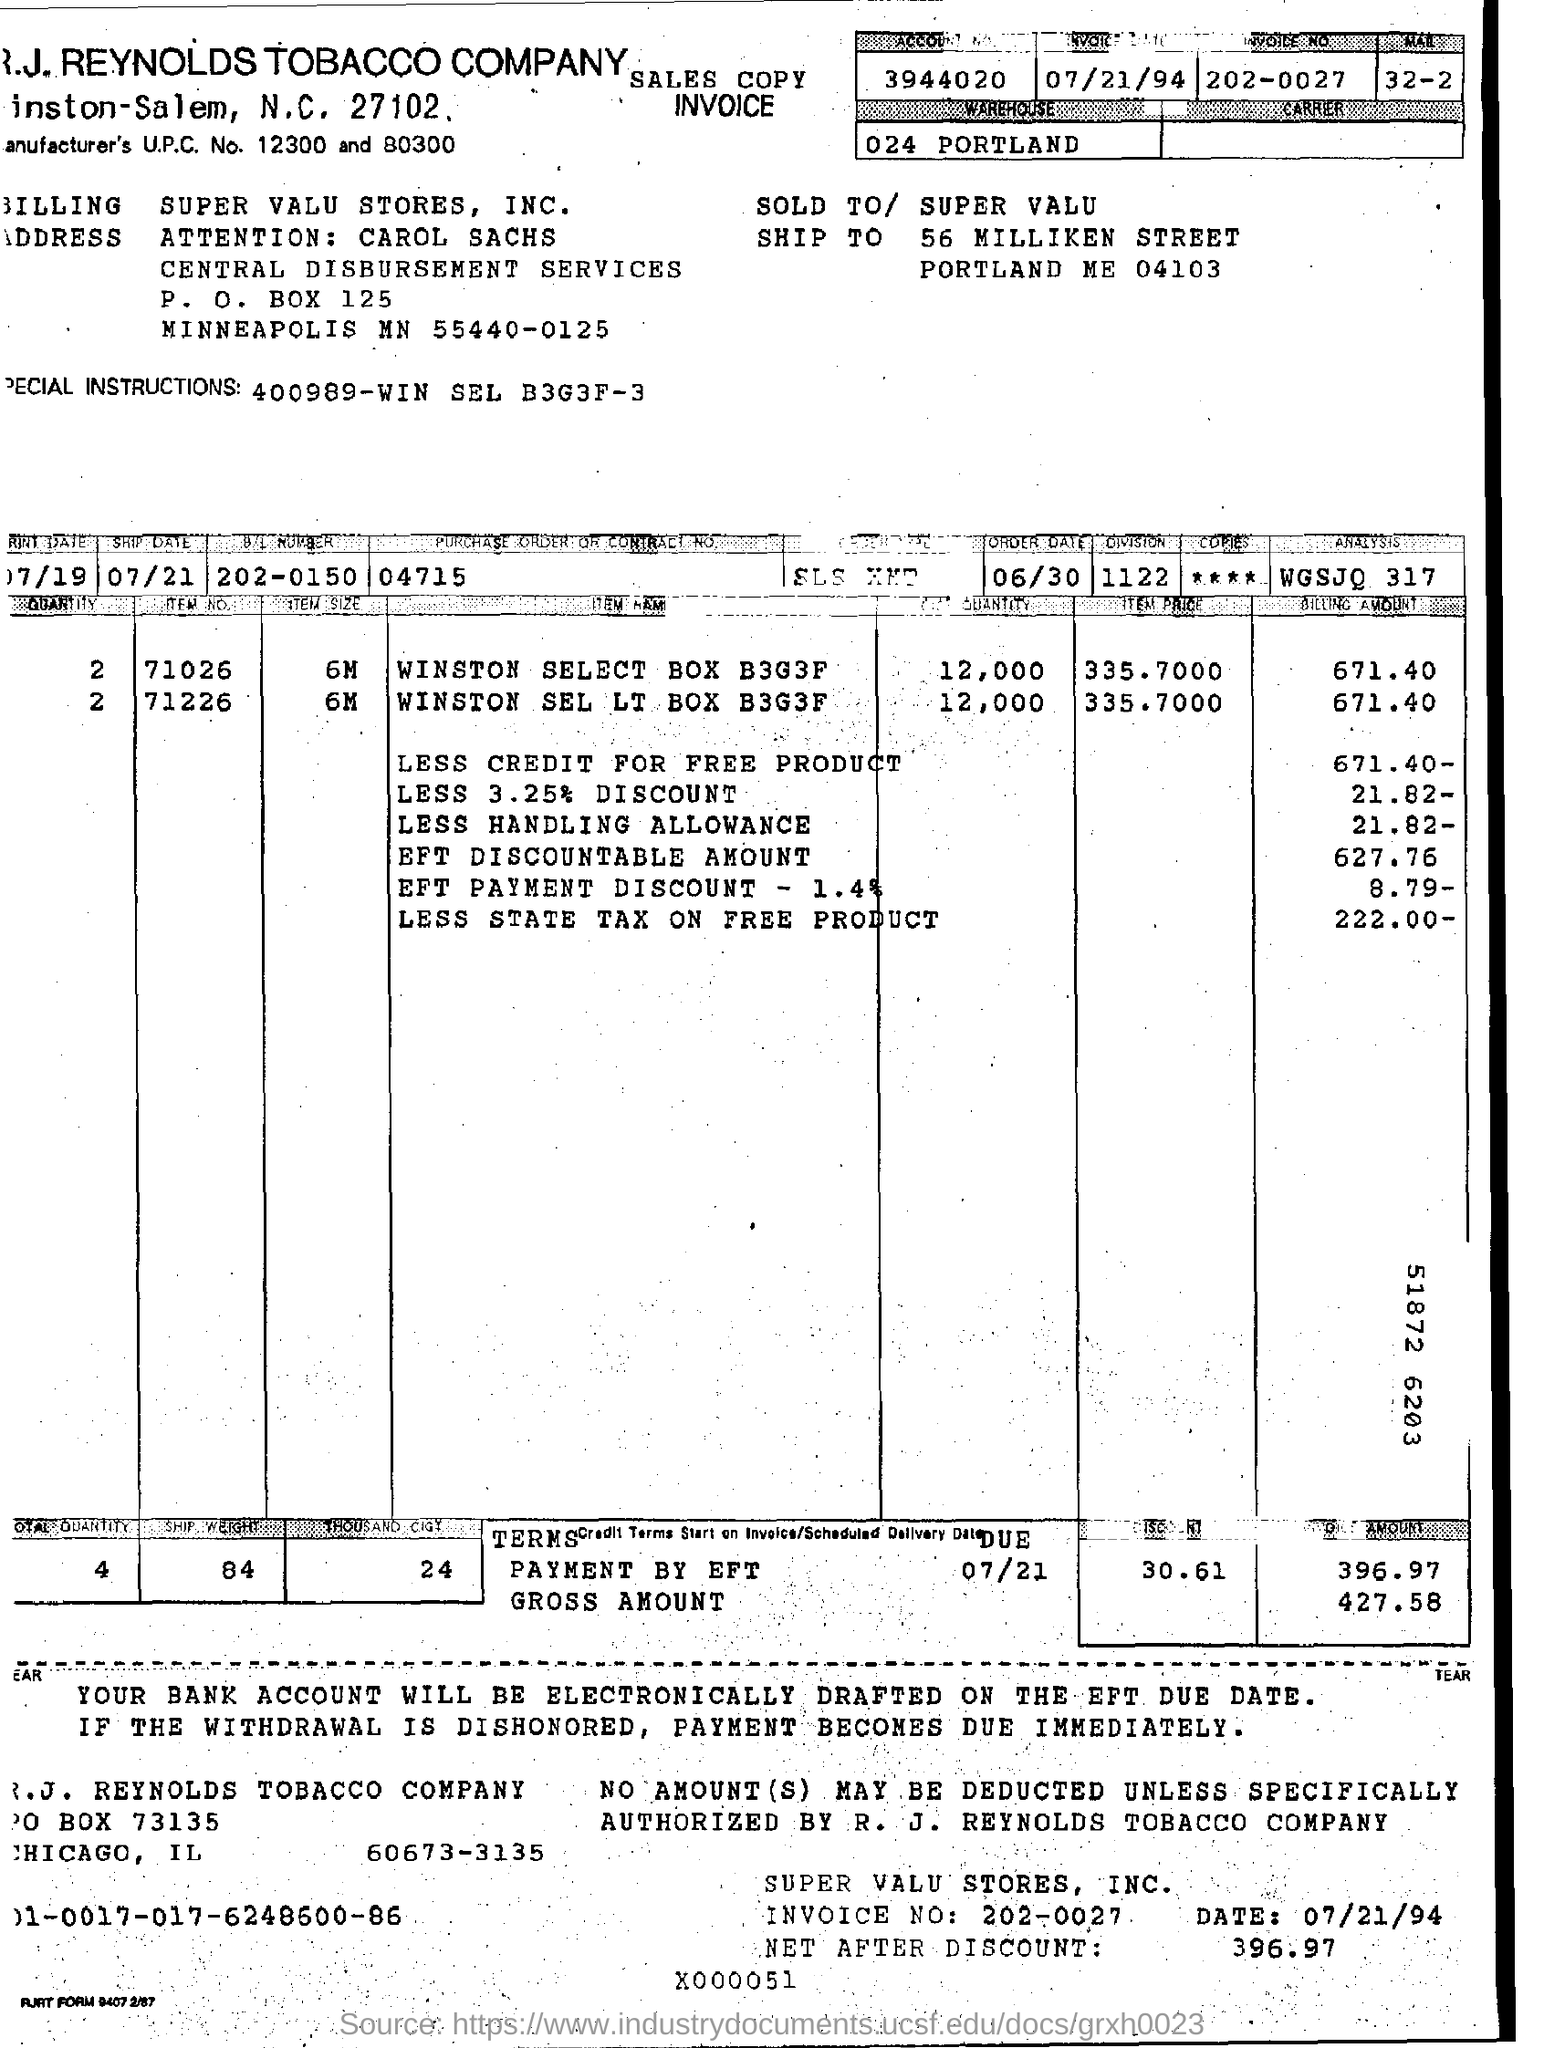Outline some significant characteristics in this image. The ship date is on 07/21.. The B/L number is 202-0150. The invoice date is July 21, 1994. The warehouse is located in Portland, as indicated by the text 'Where is the warehouse? 024 Portland..'. The invoice number is 202-0027. 